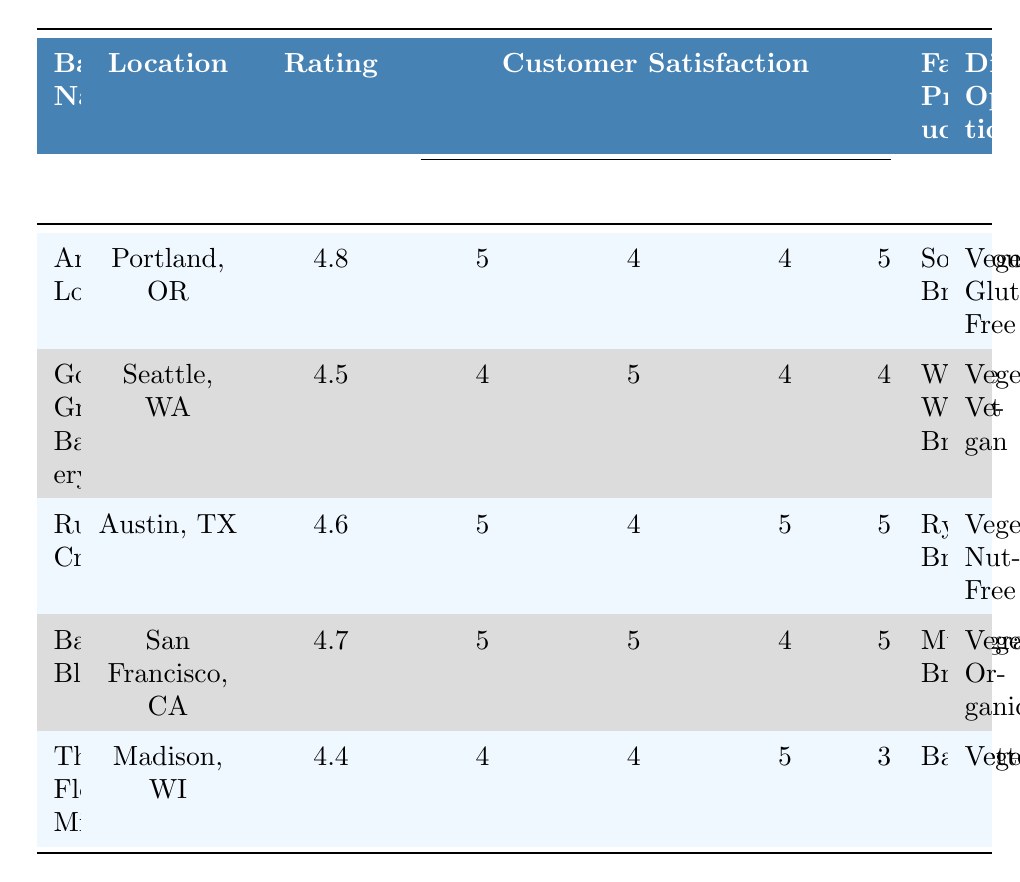What is the highest customer satisfaction rating for a bakery? The highest rating in the table is listed next to Artisan Loaf, which has a rating of 4.8.
Answer: 4.8 Which bakery has the highest score in the Quality category? Artisan Loaf scored 5 in Quality, which is the highest among all bakeries listed.
Answer: Artisan Loaf What is the favorite product of Baking Bliss? Baking Bliss's favorite product is Multigrain Bread, as mentioned in the table.
Answer: Multigrain Bread Which bakeries offer gluten-free options? Artisan Loaf is the only bakery offering gluten-free options as indicated in the Dietary Options column.
Answer: Artisan Loaf What is the average rating of the bakeries listed? The ratings are: 4.8, 4.5, 4.6, 4.7, and 4.4. Adding these gives 24.0, and dividing by 5 gives an average rating of 4.8.
Answer: 4.6 Does any bakery have a rating lower than 4.5? The Flour Mill has a rating of 4.4, which is lower than 4.5, making the statement true.
Answer: Yes What is the best-rated bakery in terms of both Quality and Atmosphere? Artisan Loaf scores a perfect 5 in both the Quality and Atmosphere categories, making it the best-rated in those aspects.
Answer: Artisan Loaf Which bakery has the widest variety of dietary options? Artisan Loaf and Baking Bliss both have two dietary options listed, but Baking Bliss offers Organic while Artisan Loaf offers Gluten-Free, making them tied in variety.
Answer: Artisan Loaf and Baking Bliss How many bakeries scored a perfect 5 in the Service category? Baking Bliss (5) and Golden Grain Bakery (5) both achieved the highest score of 5 in Service. Thus, there are two bakeries with that score.
Answer: 2 Is there any bakery that has an overall rating higher than 4.5 but has a score of 3 in the Atmosphere category? The Flour Mill has a rating of 4.4 and an Atmosphere score of 3, thus it's the only one that meets this criterion but does not have a rating greater than 4.5.
Answer: No 